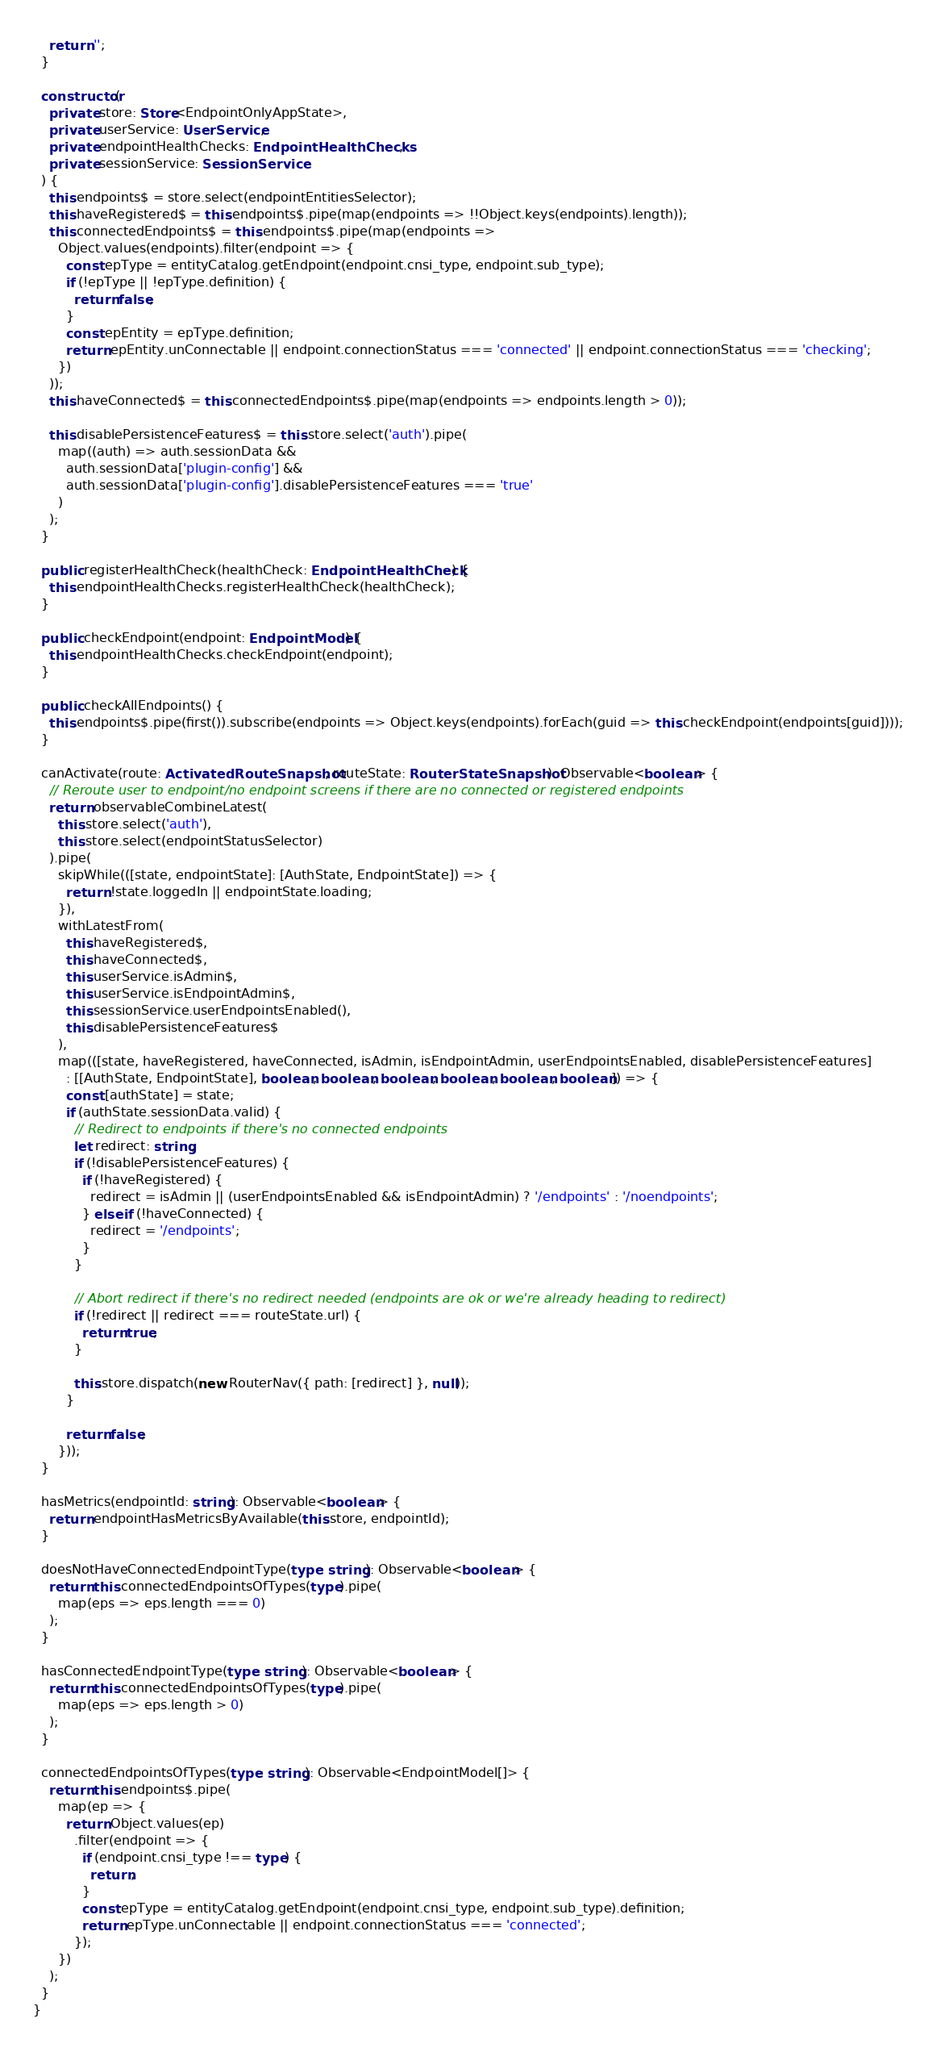<code> <loc_0><loc_0><loc_500><loc_500><_TypeScript_>    return '';
  }

  constructor(
    private store: Store<EndpointOnlyAppState>,
    private userService: UserService,
    private endpointHealthChecks: EndpointHealthChecks,
    private sessionService: SessionService
  ) {
    this.endpoints$ = store.select(endpointEntitiesSelector);
    this.haveRegistered$ = this.endpoints$.pipe(map(endpoints => !!Object.keys(endpoints).length));
    this.connectedEndpoints$ = this.endpoints$.pipe(map(endpoints =>
      Object.values(endpoints).filter(endpoint => {
        const epType = entityCatalog.getEndpoint(endpoint.cnsi_type, endpoint.sub_type);
        if (!epType || !epType.definition) {
          return false;
        }
        const epEntity = epType.definition;
        return epEntity.unConnectable || endpoint.connectionStatus === 'connected' || endpoint.connectionStatus === 'checking';
      })
    ));
    this.haveConnected$ = this.connectedEndpoints$.pipe(map(endpoints => endpoints.length > 0));

    this.disablePersistenceFeatures$ = this.store.select('auth').pipe(
      map((auth) => auth.sessionData &&
        auth.sessionData['plugin-config'] &&
        auth.sessionData['plugin-config'].disablePersistenceFeatures === 'true'
      )
    );
  }

  public registerHealthCheck(healthCheck: EndpointHealthCheck) {
    this.endpointHealthChecks.registerHealthCheck(healthCheck);
  }

  public checkEndpoint(endpoint: EndpointModel) {
    this.endpointHealthChecks.checkEndpoint(endpoint);
  }

  public checkAllEndpoints() {
    this.endpoints$.pipe(first()).subscribe(endpoints => Object.keys(endpoints).forEach(guid => this.checkEndpoint(endpoints[guid])));
  }

  canActivate(route: ActivatedRouteSnapshot, routeState: RouterStateSnapshot): Observable<boolean> {
    // Reroute user to endpoint/no endpoint screens if there are no connected or registered endpoints
    return observableCombineLatest(
      this.store.select('auth'),
      this.store.select(endpointStatusSelector)
    ).pipe(
      skipWhile(([state, endpointState]: [AuthState, EndpointState]) => {
        return !state.loggedIn || endpointState.loading;
      }),
      withLatestFrom(
        this.haveRegistered$,
        this.haveConnected$,
        this.userService.isAdmin$,
        this.userService.isEndpointAdmin$,
        this.sessionService.userEndpointsEnabled(),
        this.disablePersistenceFeatures$
      ),
      map(([state, haveRegistered, haveConnected, isAdmin, isEndpointAdmin, userEndpointsEnabled, disablePersistenceFeatures]
        : [[AuthState, EndpointState], boolean, boolean, boolean, boolean, boolean, boolean]) => {
        const [authState] = state;
        if (authState.sessionData.valid) {
          // Redirect to endpoints if there's no connected endpoints
          let redirect: string;
          if (!disablePersistenceFeatures) {
            if (!haveRegistered) {
              redirect = isAdmin || (userEndpointsEnabled && isEndpointAdmin) ? '/endpoints' : '/noendpoints';
            } else if (!haveConnected) {
              redirect = '/endpoints';
            }
          }

          // Abort redirect if there's no redirect needed (endpoints are ok or we're already heading to redirect)
          if (!redirect || redirect === routeState.url) {
            return true;
          }

          this.store.dispatch(new RouterNav({ path: [redirect] }, null));
        }

        return false;
      }));
  }

  hasMetrics(endpointId: string): Observable<boolean> {
    return endpointHasMetricsByAvailable(this.store, endpointId);
  }

  doesNotHaveConnectedEndpointType(type: string): Observable<boolean> {
    return this.connectedEndpointsOfTypes(type).pipe(
      map(eps => eps.length === 0)
    );
  }

  hasConnectedEndpointType(type: string): Observable<boolean> {
    return this.connectedEndpointsOfTypes(type).pipe(
      map(eps => eps.length > 0)
    );
  }

  connectedEndpointsOfTypes(type: string): Observable<EndpointModel[]> {
    return this.endpoints$.pipe(
      map(ep => {
        return Object.values(ep)
          .filter(endpoint => {
            if (endpoint.cnsi_type !== type) {
              return;
            }
            const epType = entityCatalog.getEndpoint(endpoint.cnsi_type, endpoint.sub_type).definition;
            return epType.unConnectable || endpoint.connectionStatus === 'connected';
          });
      })
    );
  }
}
</code> 